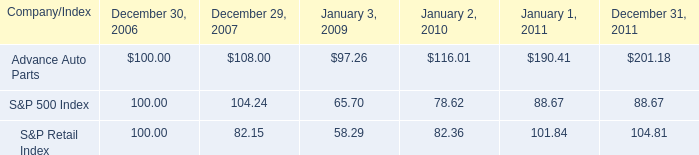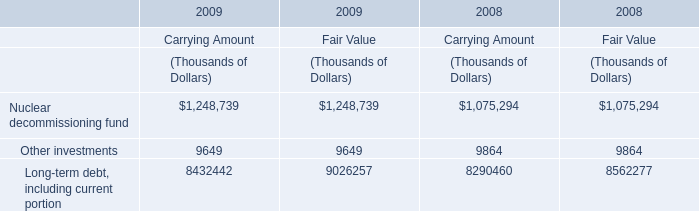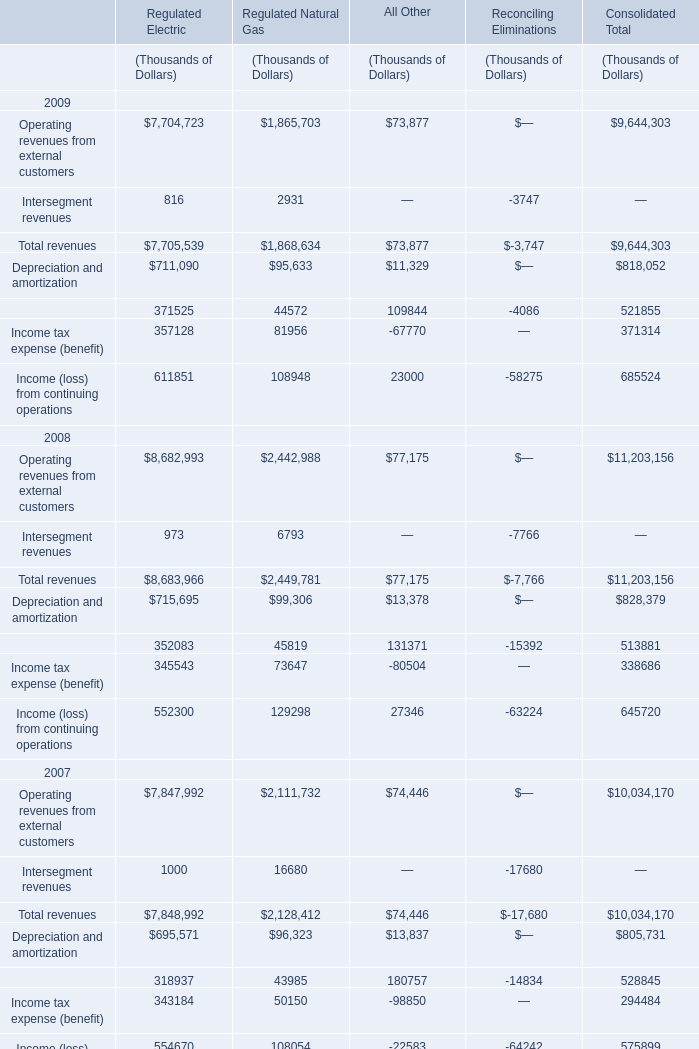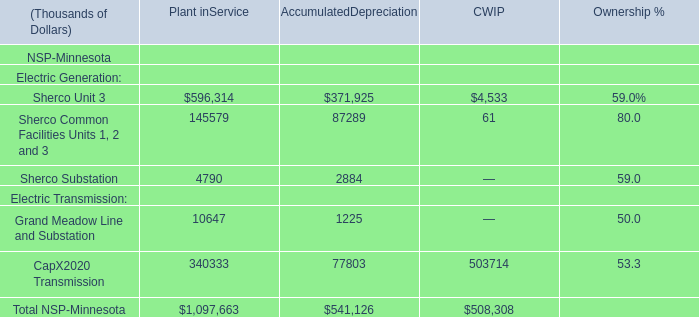What is the average value of the Total revenues for Regulated Natural Gas in 2007 , 2008 , and 2009 ? (in thousand) 
Computations: (((2128412 + 2449781) + 1868634) / 3)
Answer: 2148942.33333. 